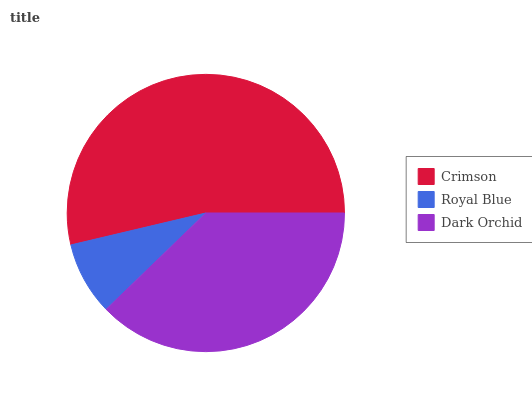Is Royal Blue the minimum?
Answer yes or no. Yes. Is Crimson the maximum?
Answer yes or no. Yes. Is Dark Orchid the minimum?
Answer yes or no. No. Is Dark Orchid the maximum?
Answer yes or no. No. Is Dark Orchid greater than Royal Blue?
Answer yes or no. Yes. Is Royal Blue less than Dark Orchid?
Answer yes or no. Yes. Is Royal Blue greater than Dark Orchid?
Answer yes or no. No. Is Dark Orchid less than Royal Blue?
Answer yes or no. No. Is Dark Orchid the high median?
Answer yes or no. Yes. Is Dark Orchid the low median?
Answer yes or no. Yes. Is Royal Blue the high median?
Answer yes or no. No. Is Royal Blue the low median?
Answer yes or no. No. 